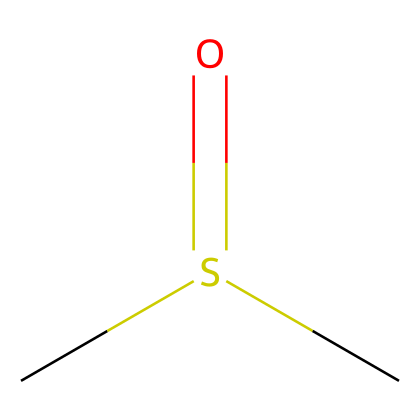What is the molecular formula of this compound? The molecular formula can be derived from the structure. This compound has two carbon (C) atoms, one sulfur (S) atom, and one oxygen (O) atom, giving the formula C2H6OS.
Answer: C2H6OS How many bonds are present in this molecule? The molecule consists of single bonds between the carbon atoms and the sulfur atom, and a double bond from the sulfur to the oxygen atom. There are a total of 4 bonds (3 single and 1 double).
Answer: 4 What functional group is present in DMSO? The structure contains a sulfur atom double bonded to an oxygen atom, indicating a sulfoxide functional group.
Answer: sulfoxide Which atom in the structure is responsible for polarity? The presence of the highly electronegative oxygen atom (O) attached to the sulfur atom contributes to the overall polarity of the molecule.
Answer: oxygen How many hydrogen atoms are attached to the carbon atoms? There are three hydrogen atoms attached to one carbon (methyl group), and two hydrogens attached to the second carbon, totaling five hydrogen atoms in this molecule.
Answer: 6 What type of chemical is DMSO classified as? Given its structure and properties, DMSO is classified as a solvent, particularly an aprotic solvent due to the absence of active hydrogen.
Answer: solvent 